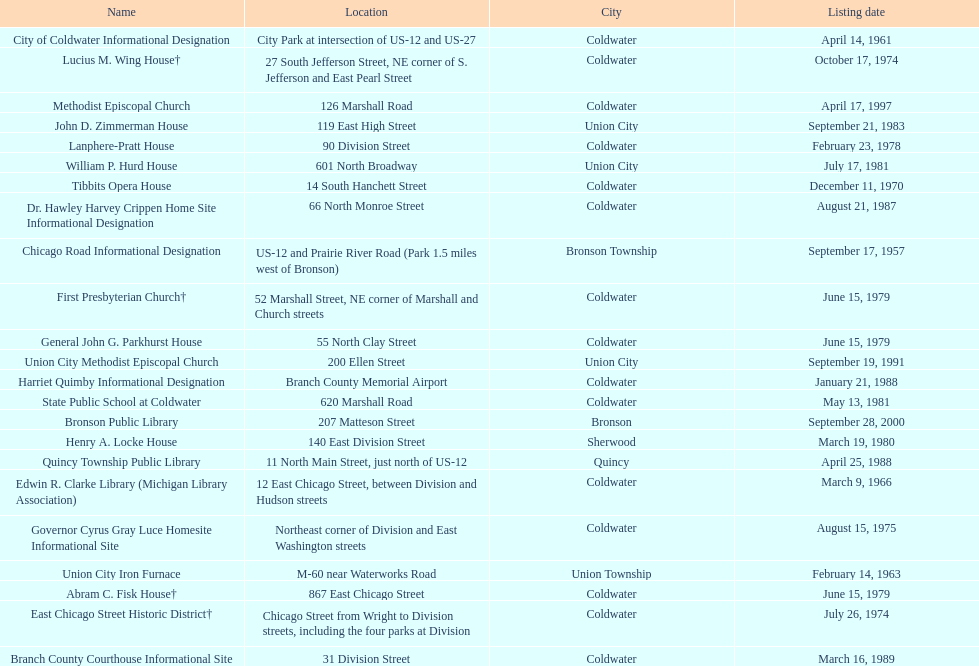What is the total current listing of names on this chart? 23. 